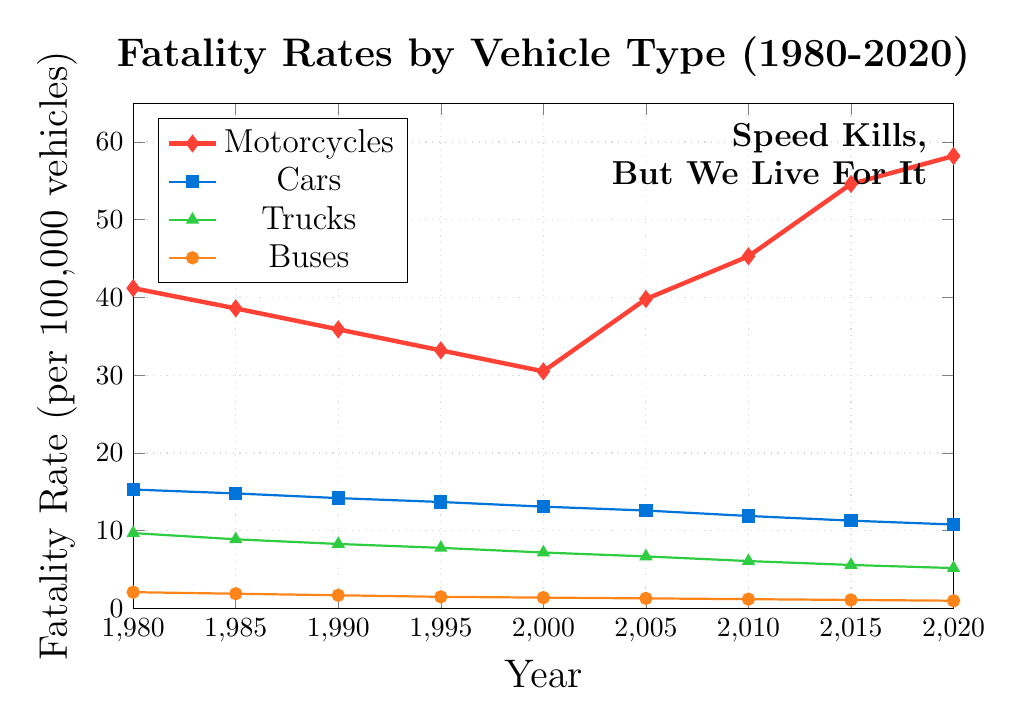What's the trend of motorcycle fatality rates from 1980 to 2020? Observe the line representing motorcycles. The line initially decreases from 1980 to 2000, then sharply rises from 2005, reaching its highest point in 2020. So, there is a U-shaped trend.
Answer: U-shaped trend Which vehicle type had the highest fatality rate in 2010? In 2010, the vertical position of the lines shows that motorcycles have the highest fatality rate compared to cars, trucks, and buses.
Answer: Motorcycles Compare the fatality rates of buses and trucks in 1995. Which was higher and by how much? In 1995, the fatality rate for buses is 1.5 and for trucks is 7.8. So, trucks had a higher fatality rate, specifically by 7.8 - 1.5 = 6.3.
Answer: Trucks, by 6.3 What is the rate of increase in motorcycle fatality rates from 2000 to 2005? The rate increased from 30.5 in 2000 to 39.8 in 2005. The difference is 39.8 - 30.5 = 9.3.
Answer: 9.3 Which vehicle type shows a consistent decrease in fatality rates over the time period? Observe the trends of each vehicle type's line. Cars, trucks, and buses show consistent decreases.
Answer: Cars, trucks, and buses How much did the fatality rate of cars decrease from 1980 to 2020? The fatality rate for cars in 1980 is 15.3 and in 2020 is 10.8. The decrease is 15.3 - 10.8 = 4.5.
Answer: 4.5 In which year did motorcycles surpass 40 in fatality rates? The motorcycle fatality rate line surpasses 40 between 2005 and 2010. Referencing exact data points, it happened in 2005 when the rate was 39.8, just below 40, and it was above 40 by 2010.
Answer: 2010 Which vehicle type had the smallest change in fatality rate between 1980 and 2020? Compare the starting and ending points of each line. Buses changed from 2.1 to 1.0, the smallest change among all vehicle types.
Answer: Buses What was the average fatality rate for motorcycles in the years 1980, 1985, and 1990? The values are 41.2, 38.6, and 35.9. Average = (41.2 + 38.6 + 35.9) / 3 = 38.57.
Answer: 38.57 